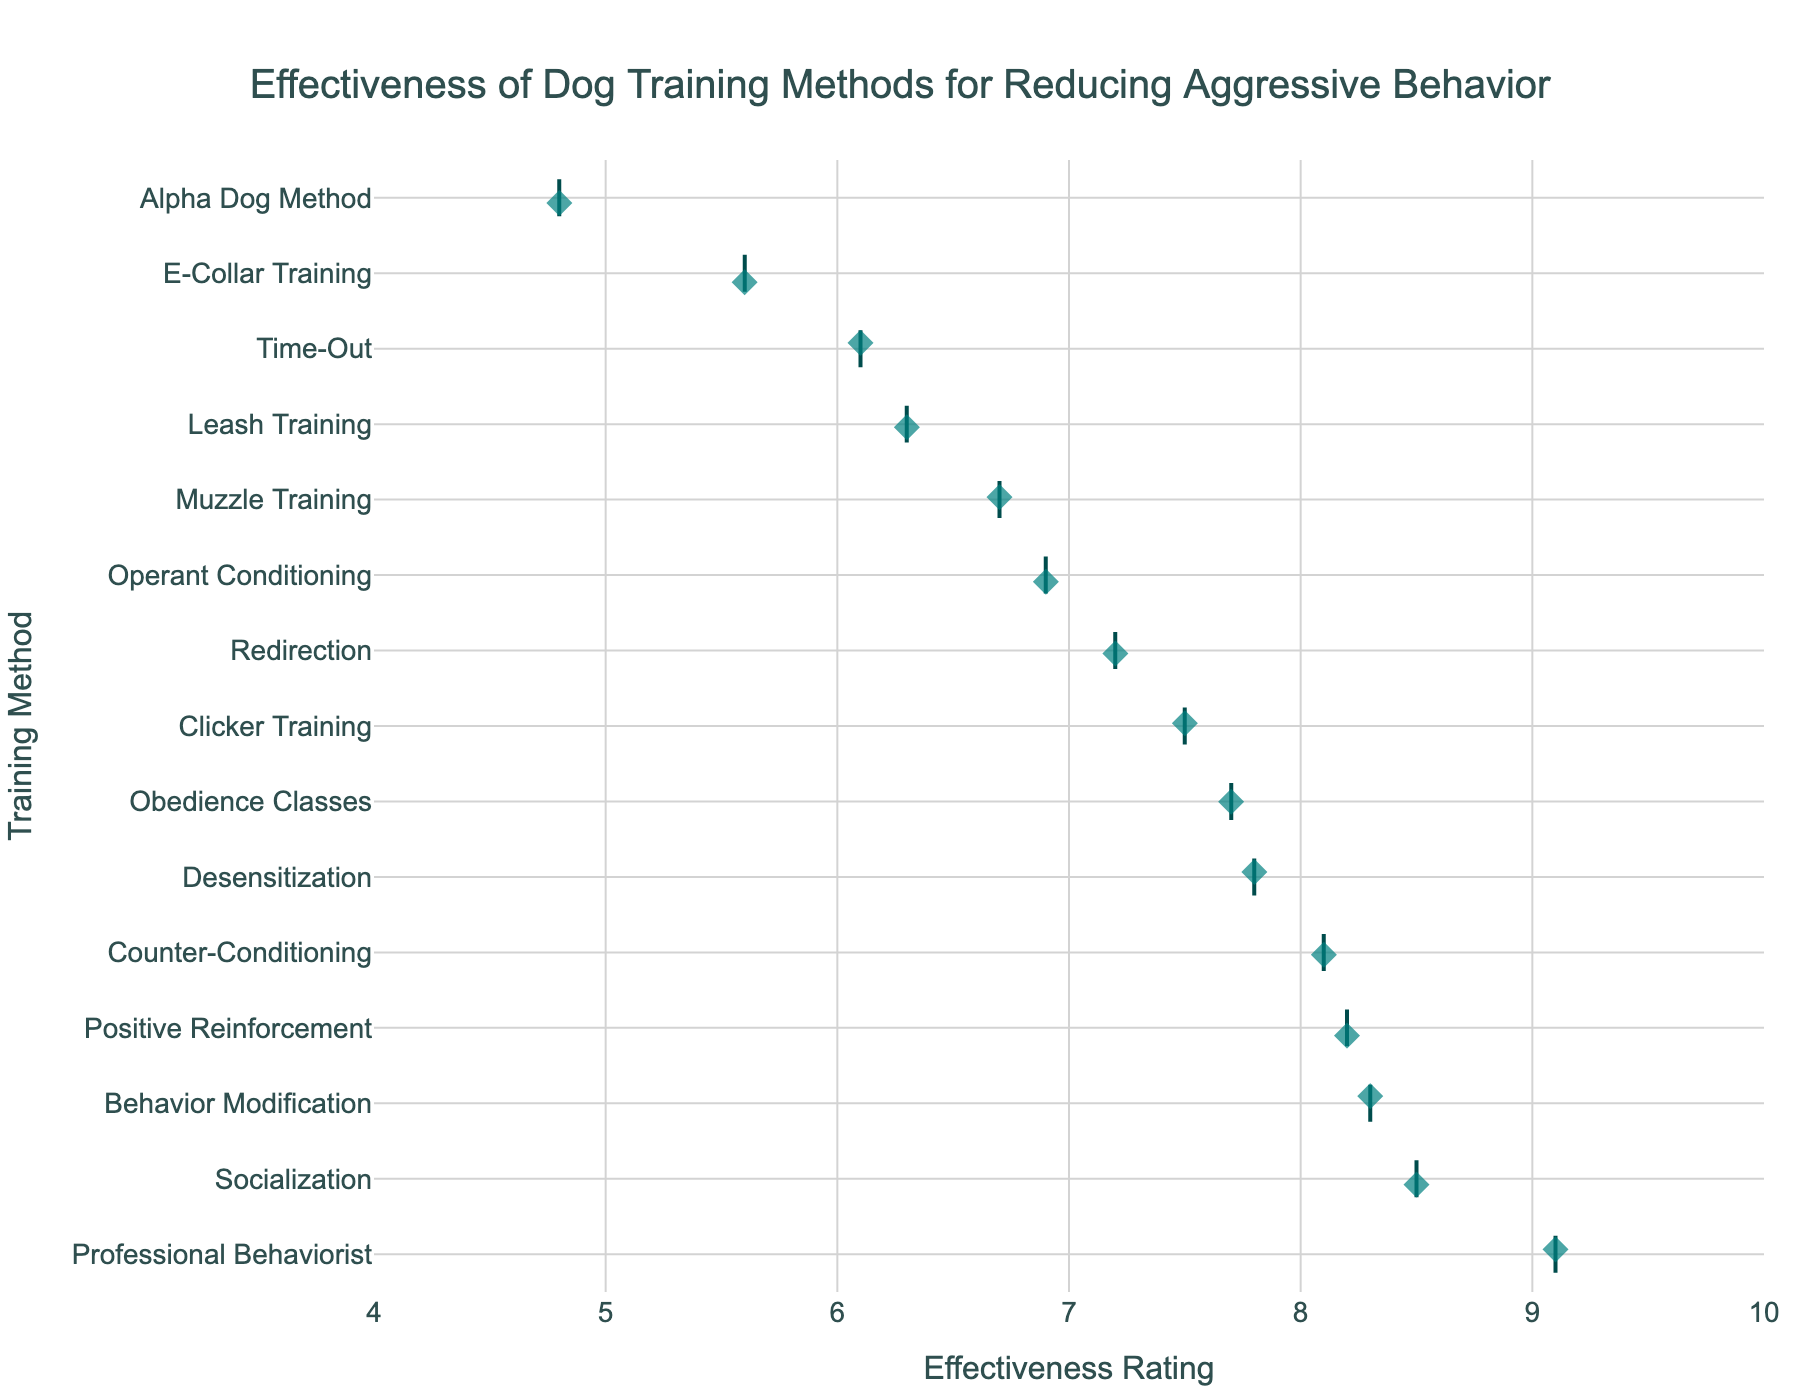What is the title of the plot? The title is typically located at the top of the plot. In this figure, it states the overall aim of the data analysis, which is indicated by the largest and most emphasized text at the top center of the chart.
Answer: Effectiveness of Dog Training Methods for Reducing Aggressive Behavior Which dog training method has the highest effectiveness rating? Look at the horizontal bar with the dot farthest to the right, which corresponds to the training method with the highest rating. This bar is located at the top if the bars were sorted accordingly.
Answer: Professional Behaviorist How many training methods have an effectiveness rating above 8.0? Count the number of training methods with their corresponding effectiveness ratings located beyond the 8.0 mark on the x-axis. These bars should extend towards the right half of the plot.
Answer: Five What is the range of effectiveness ratings in this dataset? To find the range, identify the highest and lowest effectiveness ratings on the x-axis. Subtract the lowest rating from the highest rating. The highest rating is indicated by the Professional Behaviorist, while the lowest is by the Alpha Dog Method.
Answer: 4.3 How does the effectiveness of E-Collar Training compare to Clicker Training? Identify the positions of E-Collar Training and Clicker Training on the y-axis, then compare the respective dots along the x-axis. The dot for E-Collar should be to the left of Clicker Training for lower effectiveness.
Answer: E-Collar Training is less effective than Clicker Training Which method is slightly more effective: Desensitization or Counter-Conditioning? Locate the dots for both Desensitization and Counter-Conditioning on the plot. Compare their positions on the x-axis to see which one is slightly more to the right.
Answer: Counter-Conditioning What is the median effectiveness rating of the training methods? Since median is the middle value in a sorted list, arrange all effectiveness ratings from lowest to highest and find the central value. If there are 15 methods, the 8th value in the sorted list is the median.
Answer: 7.7 How many methods have an effectiveness rating below 6.5? Count the dots located to the left of the 6.5 mark on the x-axis.
Answer: Four Are there more methods with a rating above 7.0 or below 7.0? Count the number of dots above 7.0 and those below 7.0 on the x-axis, then compare the two counts.
Answer: More methods have a rating above 7.0 What is the effectiveness rating of Socialization? Find the dot corresponding to Socialization on the y-axis and note its position on the x-axis.
Answer: 8.5 